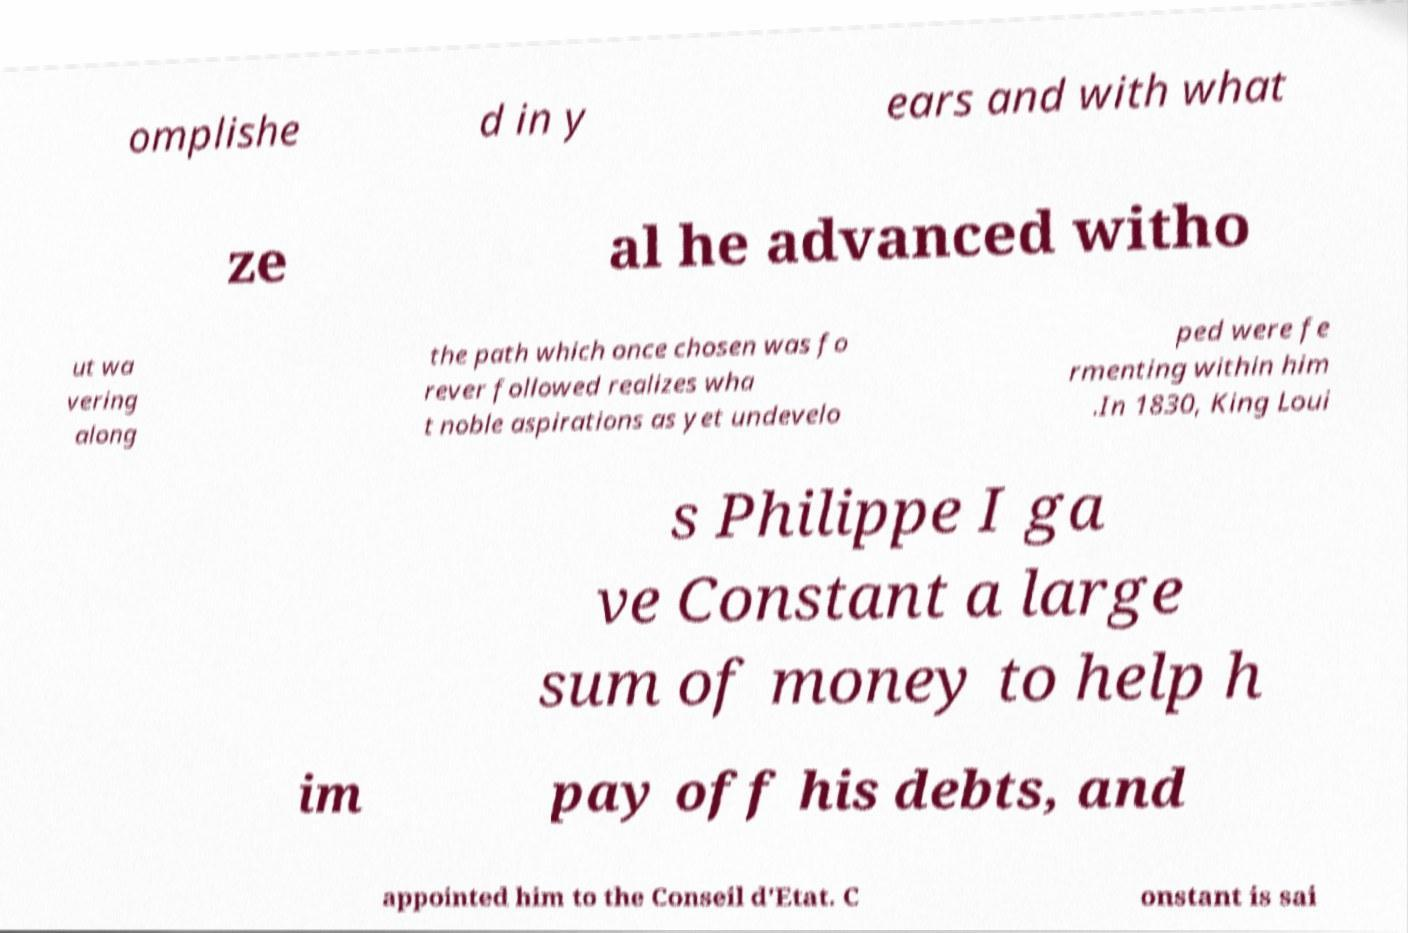Can you accurately transcribe the text from the provided image for me? omplishe d in y ears and with what ze al he advanced witho ut wa vering along the path which once chosen was fo rever followed realizes wha t noble aspirations as yet undevelo ped were fe rmenting within him .In 1830, King Loui s Philippe I ga ve Constant a large sum of money to help h im pay off his debts, and appointed him to the Conseil d'Etat. C onstant is sai 